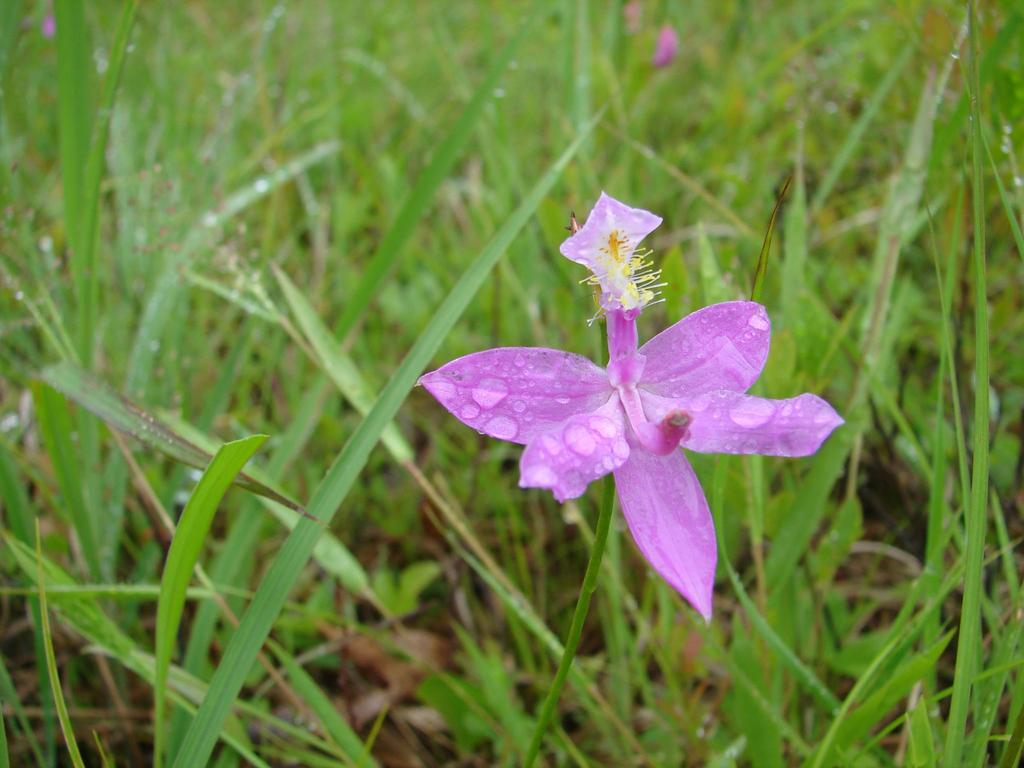What is the main subject of the image? There is a flower in the image. Where is the flower located in the image? The flower is towards the right side of the image. What color is the flower? The flower is purple in color. What can be seen in the background of the image? There is grass in the background of the image. Is the daughter driving the soda in the image? There is no daughter or soda present in the image; it features a purple flower towards the right side and grass in the background. 